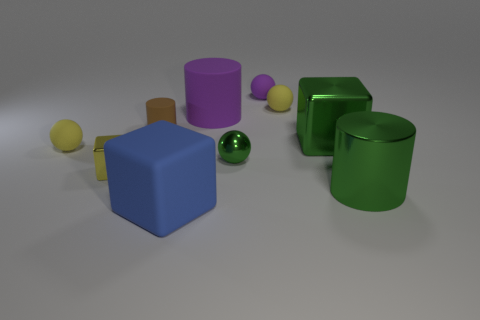Subtract all yellow cubes. Subtract all brown balls. How many cubes are left? 2 Subtract all cylinders. How many objects are left? 7 Subtract 1 green cylinders. How many objects are left? 9 Subtract all purple rubber objects. Subtract all large cylinders. How many objects are left? 6 Add 9 large rubber cylinders. How many large rubber cylinders are left? 10 Add 7 purple rubber spheres. How many purple rubber spheres exist? 8 